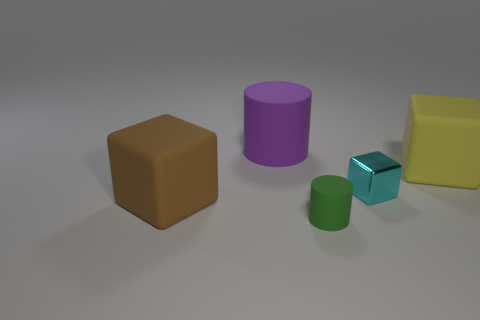What is the color of the tiny matte cylinder?
Offer a terse response. Green. What is the material of the cylinder that is in front of the brown rubber block?
Ensure brevity in your answer.  Rubber. The yellow matte thing that is the same shape as the tiny cyan metallic object is what size?
Your answer should be very brief. Large. Is the number of purple objects that are to the right of the purple object less than the number of small cyan rubber balls?
Offer a very short reply. No. Are any cyan cylinders visible?
Your answer should be very brief. No. There is another matte thing that is the same shape as the green matte thing; what is its color?
Offer a terse response. Purple. Do the purple matte object and the green cylinder have the same size?
Ensure brevity in your answer.  No. There is a green object that is the same material as the large brown thing; what is its shape?
Offer a very short reply. Cylinder. What number of other things are there of the same shape as the big brown object?
Offer a terse response. 2. There is a green rubber object on the right side of the big object that is in front of the cube behind the metal thing; what is its shape?
Provide a short and direct response. Cylinder. 